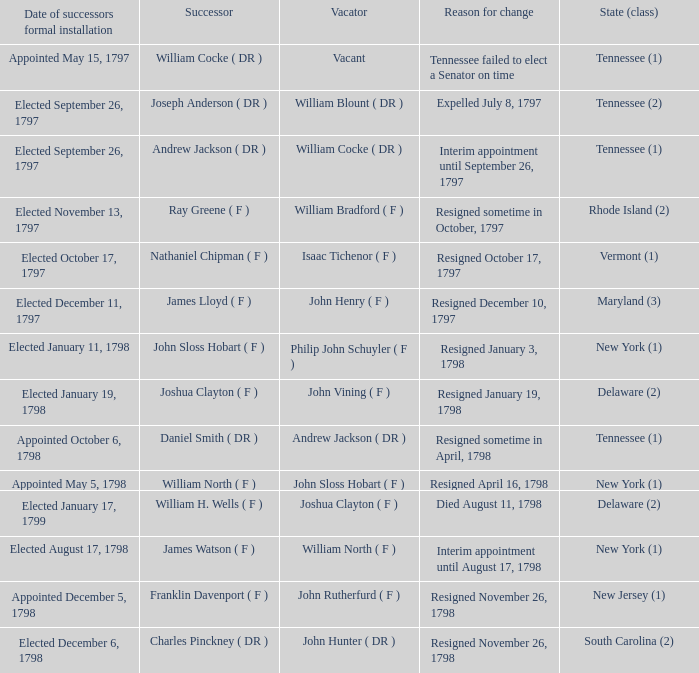Would you mind parsing the complete table? {'header': ['Date of successors formal installation', 'Successor', 'Vacator', 'Reason for change', 'State (class)'], 'rows': [['Appointed May 15, 1797', 'William Cocke ( DR )', 'Vacant', 'Tennessee failed to elect a Senator on time', 'Tennessee (1)'], ['Elected September 26, 1797', 'Joseph Anderson ( DR )', 'William Blount ( DR )', 'Expelled July 8, 1797', 'Tennessee (2)'], ['Elected September 26, 1797', 'Andrew Jackson ( DR )', 'William Cocke ( DR )', 'Interim appointment until September 26, 1797', 'Tennessee (1)'], ['Elected November 13, 1797', 'Ray Greene ( F )', 'William Bradford ( F )', 'Resigned sometime in October, 1797', 'Rhode Island (2)'], ['Elected October 17, 1797', 'Nathaniel Chipman ( F )', 'Isaac Tichenor ( F )', 'Resigned October 17, 1797', 'Vermont (1)'], ['Elected December 11, 1797', 'James Lloyd ( F )', 'John Henry ( F )', 'Resigned December 10, 1797', 'Maryland (3)'], ['Elected January 11, 1798', 'John Sloss Hobart ( F )', 'Philip John Schuyler ( F )', 'Resigned January 3, 1798', 'New York (1)'], ['Elected January 19, 1798', 'Joshua Clayton ( F )', 'John Vining ( F )', 'Resigned January 19, 1798', 'Delaware (2)'], ['Appointed October 6, 1798', 'Daniel Smith ( DR )', 'Andrew Jackson ( DR )', 'Resigned sometime in April, 1798', 'Tennessee (1)'], ['Appointed May 5, 1798', 'William North ( F )', 'John Sloss Hobart ( F )', 'Resigned April 16, 1798', 'New York (1)'], ['Elected January 17, 1799', 'William H. Wells ( F )', 'Joshua Clayton ( F )', 'Died August 11, 1798', 'Delaware (2)'], ['Elected August 17, 1798', 'James Watson ( F )', 'William North ( F )', 'Interim appointment until August 17, 1798', 'New York (1)'], ['Appointed December 5, 1798', 'Franklin Davenport ( F )', 'John Rutherfurd ( F )', 'Resigned November 26, 1798', 'New Jersey (1)'], ['Elected December 6, 1798', 'Charles Pinckney ( DR )', 'John Hunter ( DR )', 'Resigned November 26, 1798', 'South Carolina (2)']]} What are all the states (class) when the reason for change was resigned November 26, 1798 and the vacator was John Hunter ( DR )? South Carolina (2). 